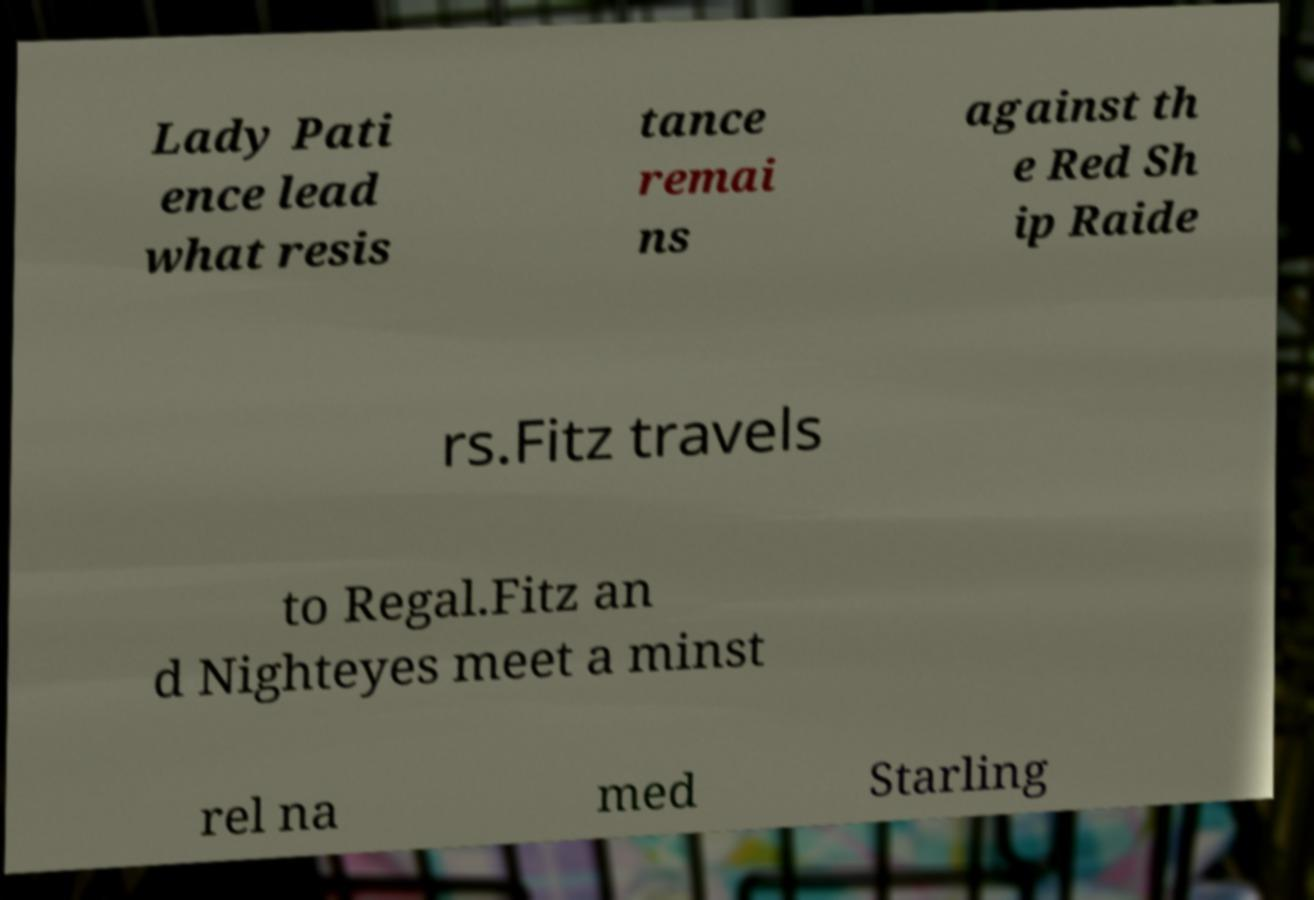What messages or text are displayed in this image? I need them in a readable, typed format. Lady Pati ence lead what resis tance remai ns against th e Red Sh ip Raide rs.Fitz travels to Regal.Fitz an d Nighteyes meet a minst rel na med Starling 